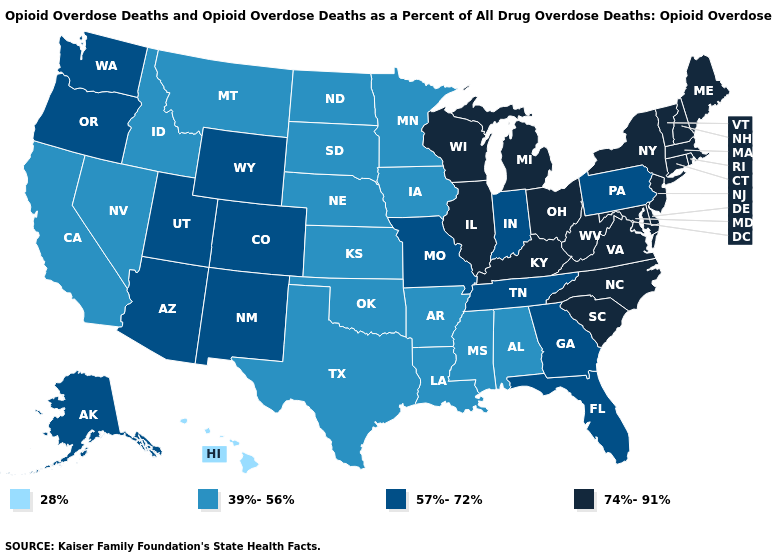What is the value of Virginia?
Answer briefly. 74%-91%. What is the lowest value in the USA?
Give a very brief answer. 28%. Name the states that have a value in the range 28%?
Concise answer only. Hawaii. Which states hav the highest value in the Northeast?
Be succinct. Connecticut, Maine, Massachusetts, New Hampshire, New Jersey, New York, Rhode Island, Vermont. Name the states that have a value in the range 39%-56%?
Answer briefly. Alabama, Arkansas, California, Idaho, Iowa, Kansas, Louisiana, Minnesota, Mississippi, Montana, Nebraska, Nevada, North Dakota, Oklahoma, South Dakota, Texas. Name the states that have a value in the range 57%-72%?
Answer briefly. Alaska, Arizona, Colorado, Florida, Georgia, Indiana, Missouri, New Mexico, Oregon, Pennsylvania, Tennessee, Utah, Washington, Wyoming. Name the states that have a value in the range 74%-91%?
Write a very short answer. Connecticut, Delaware, Illinois, Kentucky, Maine, Maryland, Massachusetts, Michigan, New Hampshire, New Jersey, New York, North Carolina, Ohio, Rhode Island, South Carolina, Vermont, Virginia, West Virginia, Wisconsin. Name the states that have a value in the range 74%-91%?
Concise answer only. Connecticut, Delaware, Illinois, Kentucky, Maine, Maryland, Massachusetts, Michigan, New Hampshire, New Jersey, New York, North Carolina, Ohio, Rhode Island, South Carolina, Vermont, Virginia, West Virginia, Wisconsin. Name the states that have a value in the range 74%-91%?
Keep it brief. Connecticut, Delaware, Illinois, Kentucky, Maine, Maryland, Massachusetts, Michigan, New Hampshire, New Jersey, New York, North Carolina, Ohio, Rhode Island, South Carolina, Vermont, Virginia, West Virginia, Wisconsin. Name the states that have a value in the range 39%-56%?
Answer briefly. Alabama, Arkansas, California, Idaho, Iowa, Kansas, Louisiana, Minnesota, Mississippi, Montana, Nebraska, Nevada, North Dakota, Oklahoma, South Dakota, Texas. What is the value of Colorado?
Short answer required. 57%-72%. Name the states that have a value in the range 74%-91%?
Be succinct. Connecticut, Delaware, Illinois, Kentucky, Maine, Maryland, Massachusetts, Michigan, New Hampshire, New Jersey, New York, North Carolina, Ohio, Rhode Island, South Carolina, Vermont, Virginia, West Virginia, Wisconsin. Name the states that have a value in the range 28%?
Answer briefly. Hawaii. What is the lowest value in states that border Louisiana?
Be succinct. 39%-56%. 